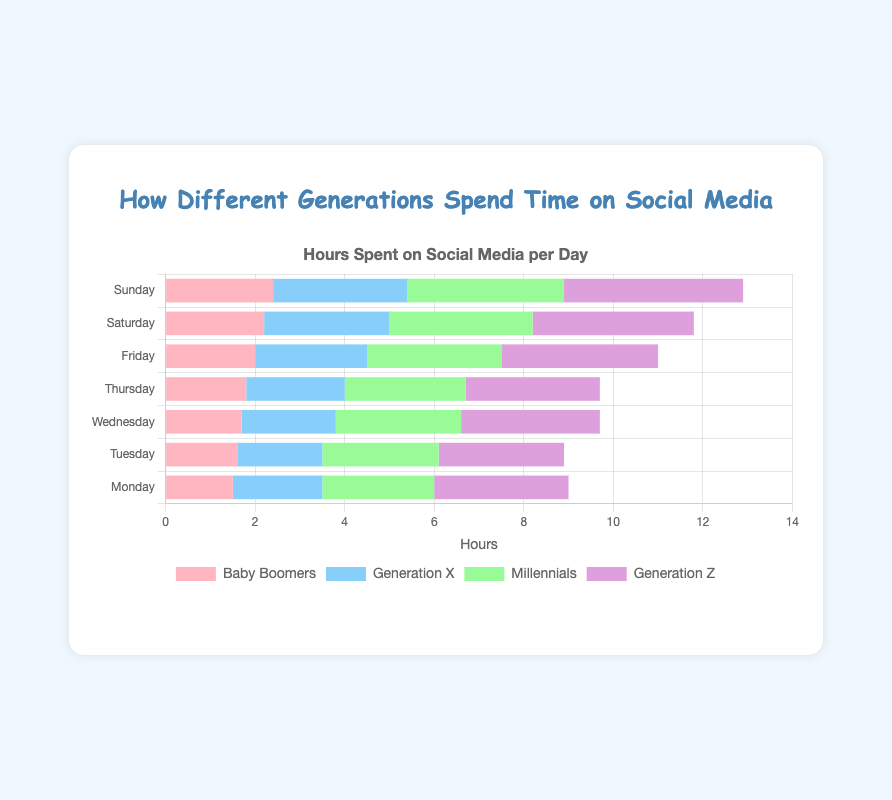What is the total number of hours spent by Baby Boomers and Generation X on social media on Monday? The hours spent by Baby Boomers on Monday is 1.5, and Generation X is 2.0. Add them together: 1.5 + 2.0 = 3.5 hours.
Answer: 3.5 On which day does Generation Z spend the most time on social media? Generation Z spends the most time on social media on Sunday, with 4.0 hours.
Answer: Sunday Which generation spends more time on social media on Friday, Millennials or Generation X? On Friday, Millennials spend 3.0 hours, and Generation X spends 2.5 hours. Thus, Millennials spend more time on social media on Friday.
Answer: Millennials What is the average time spent on social media by Millennials across the week? The total hours spent by Millennials on each day are [2.5, 2.6, 2.8, 2.7, 3.0, 3.2, 3.5]. Sum them up: 2.5 + 2.6 + 2.8 + 2.7 + 3.0 + 3.2 + 3.5 = 20.3. There are 7 days, so the average is 20.3 / 7 ≈ 2.9 hours.
Answer: 2.9 How much longer does Generation Z spend on social media on Sunday compared to Baby Boomers on the same day? Generation Z spends 4.0 hours on Sunday, and Baby Boomers spend 2.4 hours. The difference is 4.0 - 2.4 = 1.6 hours.
Answer: 1.6 Which generation shows the least variation in their time spent on social media throughout the week? We can look at the data ranges (difference between max and min value). Baby Boomers: 2.4 - 1.5 = 0.9; Generation X: 3.0 - 1.9 = 1.1; Millennials: 3.5 - 2.5 = 1.0; Generation Z: 4.0 - 2.8 = 1.2. Baby Boomers have the smallest range.
Answer: Baby Boomers What is the total time spent by all generations on Saturday? Sum the hours for each generation on Saturday: Baby Boomers (2.2), Generation X (2.8), Millennials (3.2), and Generation Z (3.6). Total = 2.2 + 2.8 + 3.2 + 3.6 = 11.8 hours.
Answer: 11.8 